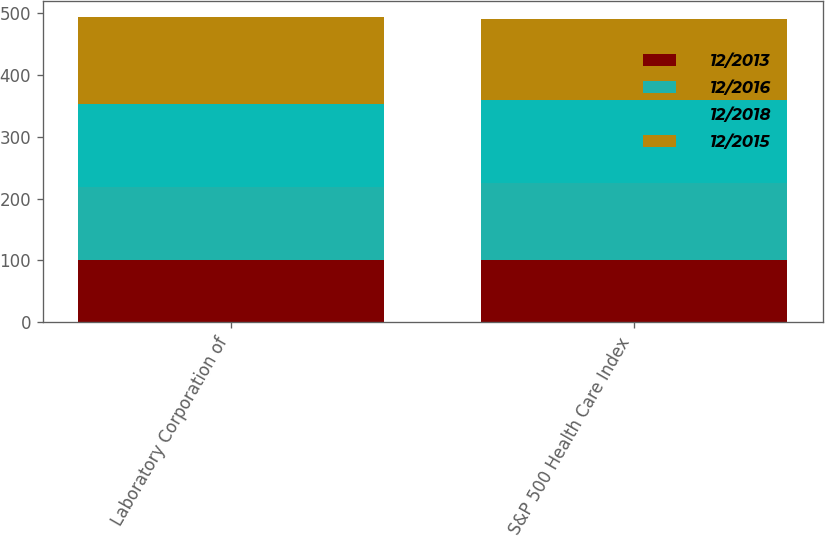Convert chart. <chart><loc_0><loc_0><loc_500><loc_500><stacked_bar_chart><ecel><fcel>Laboratory Corporation of<fcel>S&P 500 Health Care Index<nl><fcel>12/2013<fcel>100<fcel>100<nl><fcel>12/2016<fcel>118.09<fcel>125.34<nl><fcel>12/2018<fcel>135.32<fcel>133.97<nl><fcel>12/2015<fcel>140.51<fcel>130.37<nl></chart> 